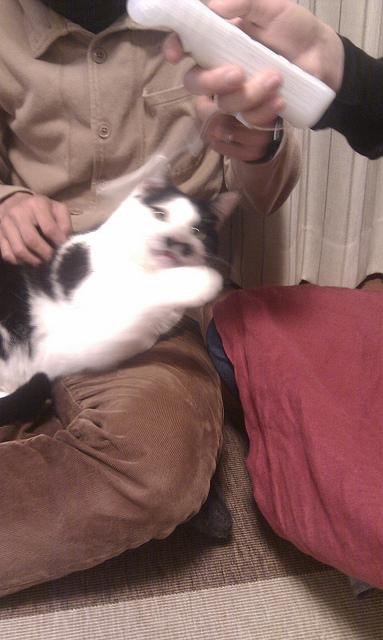What year was this video game console first released? 2006 